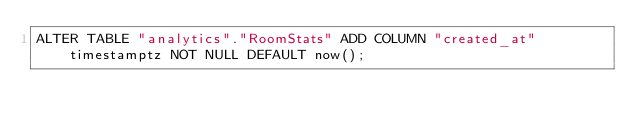<code> <loc_0><loc_0><loc_500><loc_500><_SQL_>ALTER TABLE "analytics"."RoomStats" ADD COLUMN "created_at" timestamptz NOT NULL DEFAULT now();
</code> 